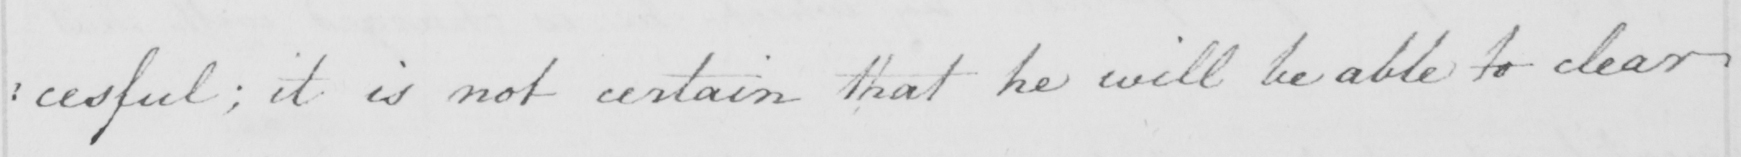Please provide the text content of this handwritten line. : cessful ; it is not certain that he will be able to clear 